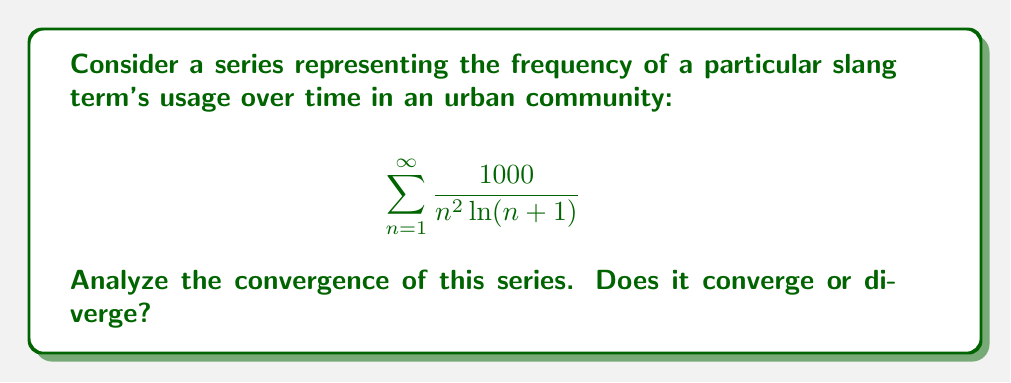Could you help me with this problem? To analyze the convergence of this series, we can use the integral test. Let's follow these steps:

1) First, define the function $f(x)$ that corresponds to the general term of the series:

   $$f(x) = \frac{1000}{x^2 \ln(x+1)}$$

2) This function is positive and decreasing for $x \geq 1$, which satisfies the conditions for the integral test.

3) Now, we need to evaluate the improper integral:

   $$\int_1^{\infty} \frac{1000}{x^2 \ln(x+1)} dx$$

4) This integral is quite complex, so we'll use comparison with a simpler function. Note that for $x \geq 1$, $\ln(x+1) > \ln(x)$. Therefore:

   $$\frac{1000}{x^2 \ln(x+1)} < \frac{1000}{x^2 \ln(x)}$$

5) So, if $\int_1^{\infty} \frac{1000}{x^2 \ln(x)} dx$ converges, our original integral will also converge.

6) Let's evaluate this simpler integral:

   $$\int_1^{\infty} \frac{1000}{x^2 \ln(x)} dx = 1000 \int_1^{\infty} \frac{1}{x^2 \ln(x)} dx$$

7) Use the substitution $u = \ln(x)$, $du = \frac{1}{x} dx$:

   $$1000 \int_0^{\infty} \frac{1}{xe^x u} du = 1000 \int_0^{\infty} \frac{e^{-x}}{u} du$$

8) This last integral is known to converge (it's related to the exponential integral function).

9) Since this simpler integral converges, our original integral must also converge.

10) By the integral test, if the integral converges, the series also converges.

Therefore, the series $\sum_{n=1}^{\infty} \frac{1000}{n^2 \ln(n+1)}$ converges.
Answer: The series $\sum_{n=1}^{\infty} \frac{1000}{n^2 \ln(n+1)}$ converges. 